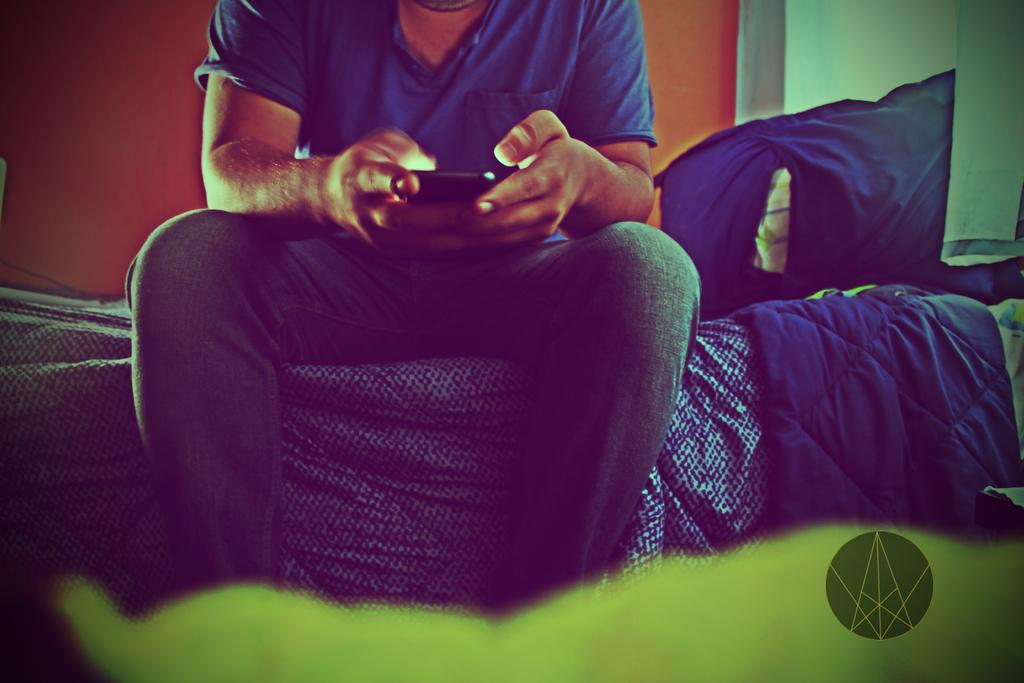What is the person in the image doing? The person is sitting in the image. What object is the person holding? The person is holding a mobile. What can be seen in the background of the image? There is a wall in the background of the image. What type of cake is the robin eating in the image? There is no robin or cake present in the image. 